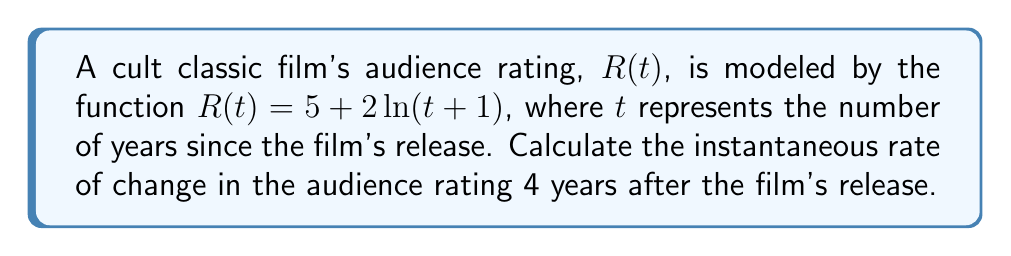Teach me how to tackle this problem. To find the instantaneous rate of change in the audience rating 4 years after the film's release, we need to calculate the derivative of the function $R(t)$ and evaluate it at $t=4$. Let's follow these steps:

1) The given function is $R(t) = 5 + 2\ln(t+1)$

2) To find the derivative, we use the chain rule:
   $$\frac{dR}{dt} = 0 + 2 \cdot \frac{d}{dt}[\ln(t+1)]$$

3) The derivative of $\ln(x)$ is $\frac{1}{x}$, so:
   $$\frac{dR}{dt} = 2 \cdot \frac{1}{t+1} \cdot \frac{d}{dt}[t+1] = 2 \cdot \frac{1}{t+1} \cdot 1$$

4) Simplifying:
   $$\frac{dR}{dt} = \frac{2}{t+1}$$

5) Now, we evaluate this at $t=4$:
   $$\frac{dR}{dt}\bigg|_{t=4} = \frac{2}{4+1} = \frac{2}{5} = 0.4$$

Therefore, 4 years after the film's release, the instantaneous rate of change in the audience rating is 0.4 rating points per year.
Answer: 0.4 rating points per year 